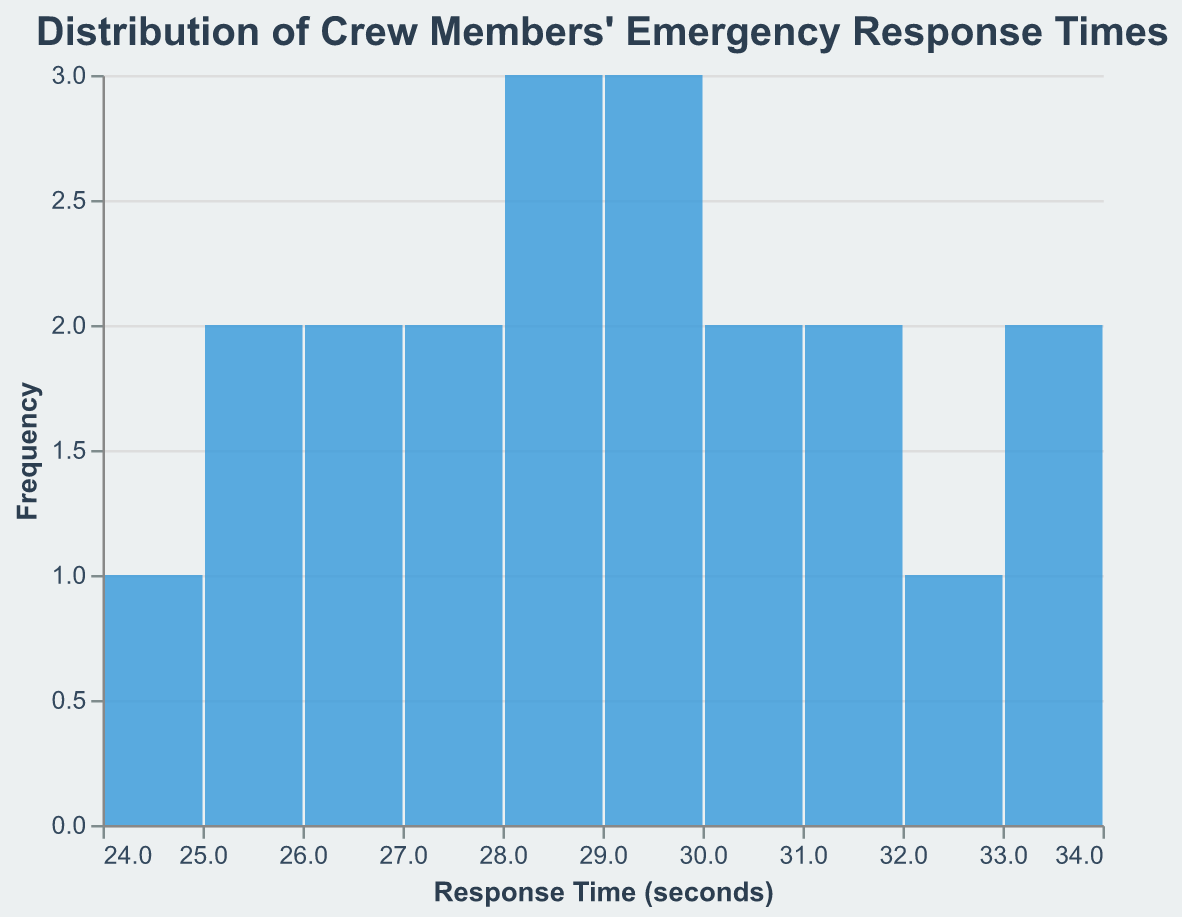What is the title of the figure? The title is written at the top of the figure. It reads "Distribution of Crew Members' Emergency Response Times".
Answer: Distribution of Crew Members' Emergency Response Times What is the range of response times shown on the x-axis? The x-axis displays a range of emergency response times in seconds. The values go from approximately 24 seconds to 34 seconds.
Answer: 24 to 34 seconds How many crew members have a response time between 28 and 30 seconds? Look at the number of bars between 28 and 30 seconds on the x-axis, counting their heights. The values indicate there are multiple bars representing different counts.
Answer: 8 Which response time range has the highest frequency? Identify the tallest bar along the x-axis, which corresponds to the range with the highest count. The height of this bar indicates the frequency.
Answer: The 28-30 seconds range Is there any crew member with a response time below 24 seconds? Examine the plotted bars on the x-axis to check if any bars or data points exist below 24 seconds. None are present below this value.
Answer: No How many crew members participated in the simulated evacuations? Sum up the total frequency heights of all bars to get the total number of participants. There are 20 data points as seen from the total count of bars' heights.
Answer: 20 What can be considered the most common response time based on the figure? The most common response time would correspond to the range with the highest bar. Examine the tallest bar to determine which range it falls into.
Answer: Approximately 28-30 seconds What is the median response time for the crew members? The median response time falls in the middle of the distribution's values. With 20 participants, the median would be the average of the 10th and 11th values. By analyzing the response times, this would fall approximately within the 28-29 seconds range.
Answer: 28.5 seconds Do any crew members have a response time above 33 seconds? Check if there are any bars on the x-axis above the 33-second mark. There is one bar that indicates a single frequency at 34 seconds.
Answer: Yes What is the frequency of crew members who took between 25 and 27 seconds to respond? Locate the bars on the x-axis representing 25-27 seconds and sum their frequencies. This results in a total frequency of 5.
Answer: 5 